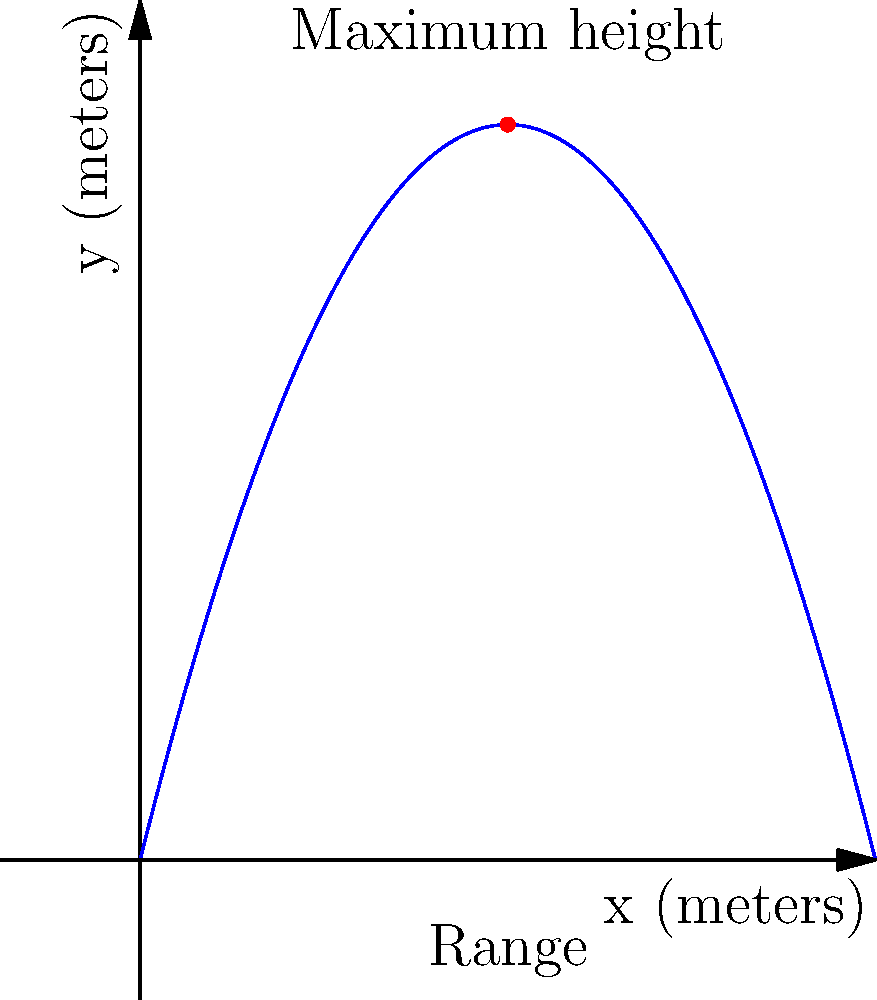During a virtual Zumba class, you demonstrate throwing a fitness ball. The ball's trajectory follows a parabolic path described by the function $f(x) = -0.5x^2 + 4x$, where $x$ is the horizontal distance and $f(x)$ is the height, both measured in meters. What is the maximum height reached by the ball, and at what horizontal distance does this occur? To find the maximum height and its corresponding horizontal distance:

1) The parabola's axis of symmetry occurs at the vertex, which is the highest point.

2) For a quadratic function in the form $f(x) = ax^2 + bx + c$, the x-coordinate of the vertex is given by $x = -\frac{b}{2a}$.

3) In this case, $a = -0.5$ and $b = 4$. So:

   $x = -\frac{4}{2(-0.5)} = -\frac{4}{-1} = 4$ meters

4) To find the maximum height, substitute $x = 4$ into the original function:

   $f(4) = -0.5(4)^2 + 4(4) = -0.5(16) + 16 = -8 + 16 = 8$ meters

Therefore, the ball reaches its maximum height of 8 meters at a horizontal distance of 4 meters.
Answer: Maximum height: 8 meters at 4 meters horizontally 